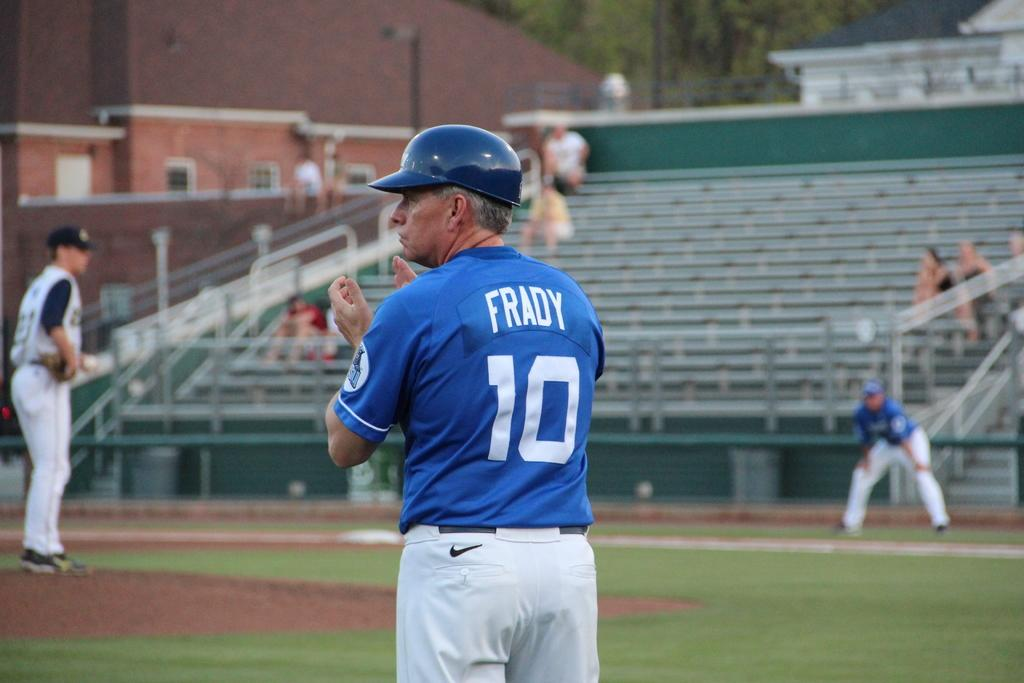<image>
Offer a succinct explanation of the picture presented. number 10 Frady clapping at other players on field and stands are almost empty 